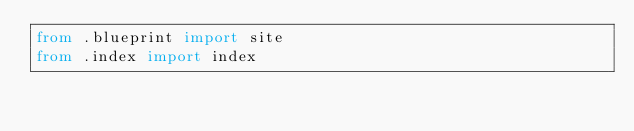Convert code to text. <code><loc_0><loc_0><loc_500><loc_500><_Python_>from .blueprint import site
from .index import index
</code> 